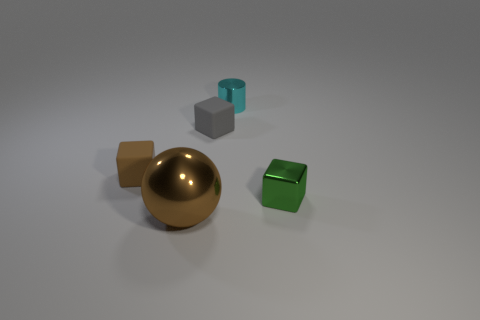Is there any other thing that has the same material as the brown ball?
Provide a short and direct response. Yes. What is the cube that is on the right side of the small metal object behind the metallic block made of?
Ensure brevity in your answer.  Metal. What size is the brown thing that is behind the green metal cube to the right of the tiny cyan metal cylinder that is behind the tiny green thing?
Provide a short and direct response. Small. What number of other things are there of the same shape as the large brown object?
Ensure brevity in your answer.  0. There is a small thing that is in front of the brown rubber object; does it have the same color as the matte block in front of the tiny gray matte object?
Provide a succinct answer. No. What is the color of the metal block that is the same size as the metal cylinder?
Offer a very short reply. Green. Is there a tiny thing that has the same color as the tiny shiny cylinder?
Offer a terse response. No. Is the size of the matte object that is in front of the gray rubber thing the same as the brown sphere?
Offer a very short reply. No. Are there an equal number of large metal spheres to the right of the metal cylinder and small blue cylinders?
Ensure brevity in your answer.  Yes. How many objects are small things that are left of the small cyan cylinder or tiny cubes?
Your answer should be compact. 3. 